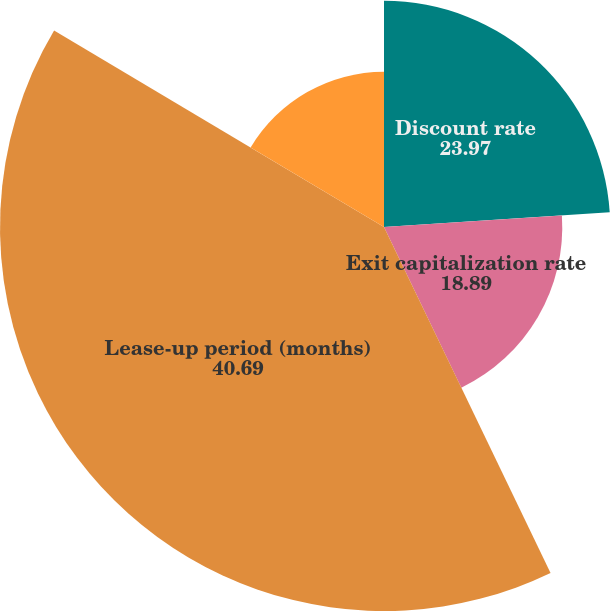<chart> <loc_0><loc_0><loc_500><loc_500><pie_chart><fcel>Discount rate<fcel>Exit capitalization rate<fcel>Lease-up period (months)<fcel>Net rental rate per square<nl><fcel>23.97%<fcel>18.89%<fcel>40.69%<fcel>16.45%<nl></chart> 